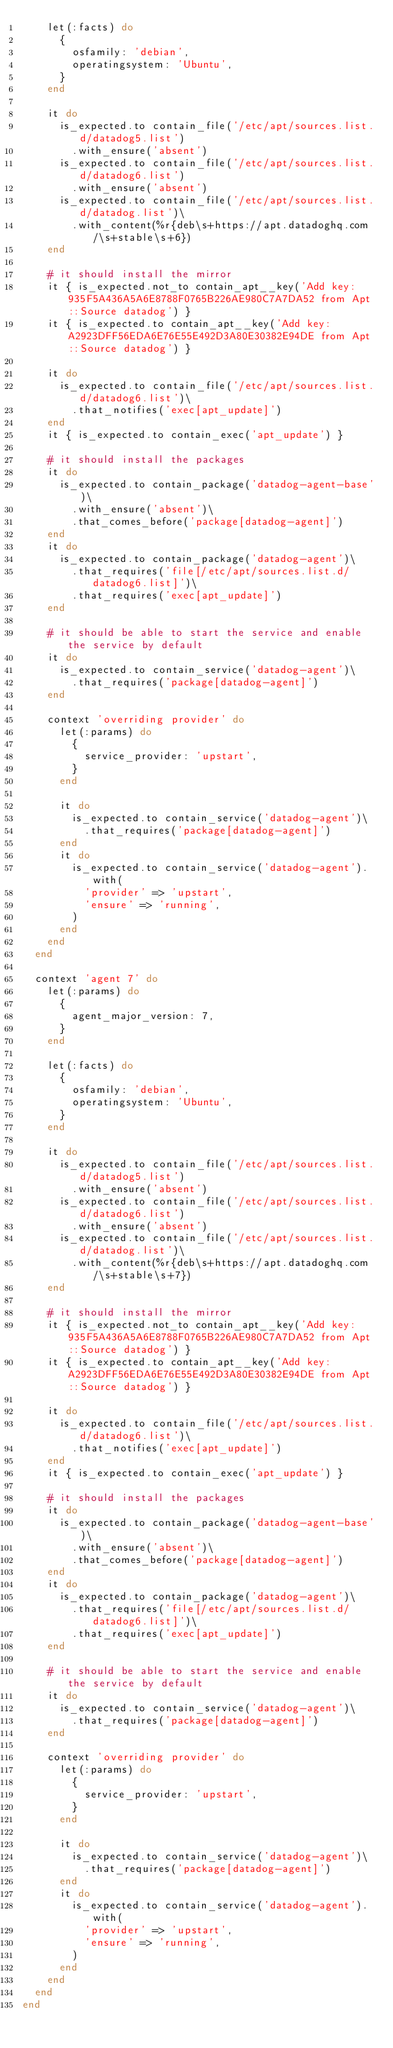<code> <loc_0><loc_0><loc_500><loc_500><_Ruby_>    let(:facts) do
      {
        osfamily: 'debian',
        operatingsystem: 'Ubuntu',
      }
    end

    it do
      is_expected.to contain_file('/etc/apt/sources.list.d/datadog5.list')
        .with_ensure('absent')
      is_expected.to contain_file('/etc/apt/sources.list.d/datadog6.list')
        .with_ensure('absent')
      is_expected.to contain_file('/etc/apt/sources.list.d/datadog.list')\
        .with_content(%r{deb\s+https://apt.datadoghq.com/\s+stable\s+6})
    end

    # it should install the mirror
    it { is_expected.not_to contain_apt__key('Add key: 935F5A436A5A6E8788F0765B226AE980C7A7DA52 from Apt::Source datadog') }
    it { is_expected.to contain_apt__key('Add key: A2923DFF56EDA6E76E55E492D3A80E30382E94DE from Apt::Source datadog') }

    it do
      is_expected.to contain_file('/etc/apt/sources.list.d/datadog6.list')\
        .that_notifies('exec[apt_update]')
    end
    it { is_expected.to contain_exec('apt_update') }

    # it should install the packages
    it do
      is_expected.to contain_package('datadog-agent-base')\
        .with_ensure('absent')\
        .that_comes_before('package[datadog-agent]')
    end
    it do
      is_expected.to contain_package('datadog-agent')\
        .that_requires('file[/etc/apt/sources.list.d/datadog6.list]')\
        .that_requires('exec[apt_update]')
    end

    # it should be able to start the service and enable the service by default
    it do
      is_expected.to contain_service('datadog-agent')\
        .that_requires('package[datadog-agent]')
    end

    context 'overriding provider' do
      let(:params) do
        {
          service_provider: 'upstart',
        }
      end

      it do
        is_expected.to contain_service('datadog-agent')\
          .that_requires('package[datadog-agent]')
      end
      it do
        is_expected.to contain_service('datadog-agent').with(
          'provider' => 'upstart',
          'ensure' => 'running',
        )
      end
    end
  end

  context 'agent 7' do
    let(:params) do
      {
        agent_major_version: 7,
      }
    end

    let(:facts) do
      {
        osfamily: 'debian',
        operatingsystem: 'Ubuntu',
      }
    end

    it do
      is_expected.to contain_file('/etc/apt/sources.list.d/datadog5.list')
        .with_ensure('absent')
      is_expected.to contain_file('/etc/apt/sources.list.d/datadog6.list')
        .with_ensure('absent')
      is_expected.to contain_file('/etc/apt/sources.list.d/datadog.list')\
        .with_content(%r{deb\s+https://apt.datadoghq.com/\s+stable\s+7})
    end

    # it should install the mirror
    it { is_expected.not_to contain_apt__key('Add key: 935F5A436A5A6E8788F0765B226AE980C7A7DA52 from Apt::Source datadog') }
    it { is_expected.to contain_apt__key('Add key: A2923DFF56EDA6E76E55E492D3A80E30382E94DE from Apt::Source datadog') }

    it do
      is_expected.to contain_file('/etc/apt/sources.list.d/datadog6.list')\
        .that_notifies('exec[apt_update]')
    end
    it { is_expected.to contain_exec('apt_update') }

    # it should install the packages
    it do
      is_expected.to contain_package('datadog-agent-base')\
        .with_ensure('absent')\
        .that_comes_before('package[datadog-agent]')
    end
    it do
      is_expected.to contain_package('datadog-agent')\
        .that_requires('file[/etc/apt/sources.list.d/datadog6.list]')\
        .that_requires('exec[apt_update]')
    end

    # it should be able to start the service and enable the service by default
    it do
      is_expected.to contain_service('datadog-agent')\
        .that_requires('package[datadog-agent]')
    end

    context 'overriding provider' do
      let(:params) do
        {
          service_provider: 'upstart',
        }
      end

      it do
        is_expected.to contain_service('datadog-agent')\
          .that_requires('package[datadog-agent]')
      end
      it do
        is_expected.to contain_service('datadog-agent').with(
          'provider' => 'upstart',
          'ensure' => 'running',
        )
      end
    end
  end
end
</code> 